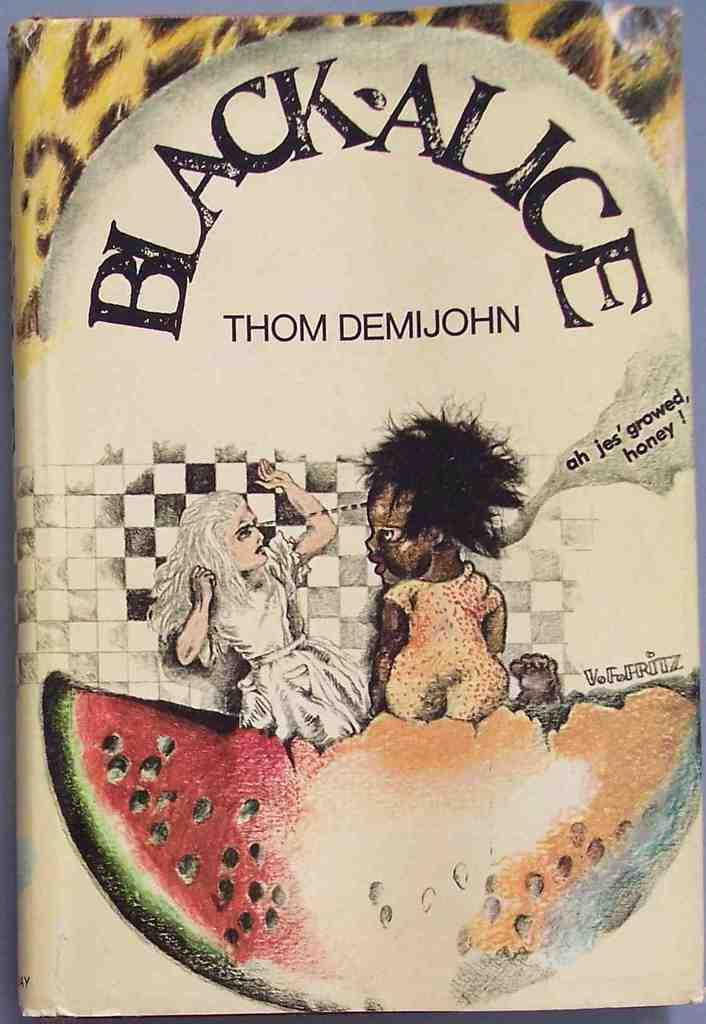What is the main subject of the image? The main subject of the image is the cover page of a book. What can be found on the cover page? There is text on the cover page. Are there any other objects or elements in the image besides the book cover? Yes, there is a fruit in the image that resembles a watermelon. Where is the fruit located in the image? The fruit is located at the bottom of the picture. Can you hear the sound of bells in the image? There is no mention of bells or any sound in the image, so it is not possible to hear any sounds. 